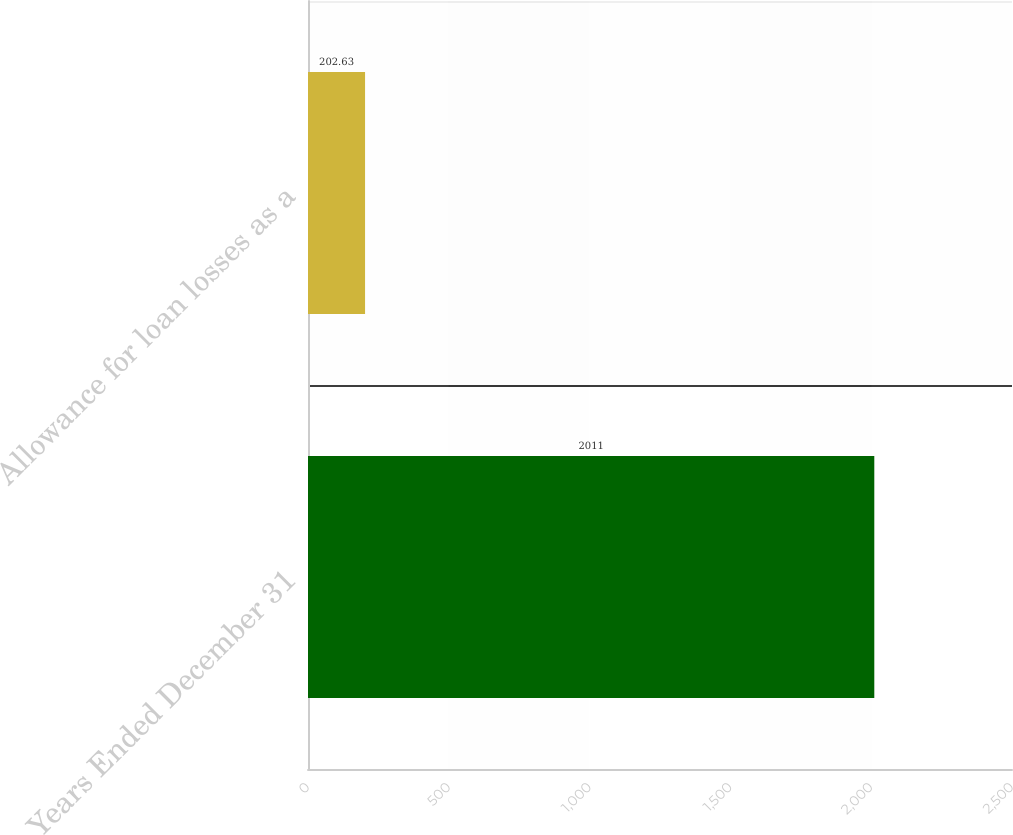Convert chart. <chart><loc_0><loc_0><loc_500><loc_500><bar_chart><fcel>Years Ended December 31<fcel>Allowance for loan losses as a<nl><fcel>2011<fcel>202.63<nl></chart> 